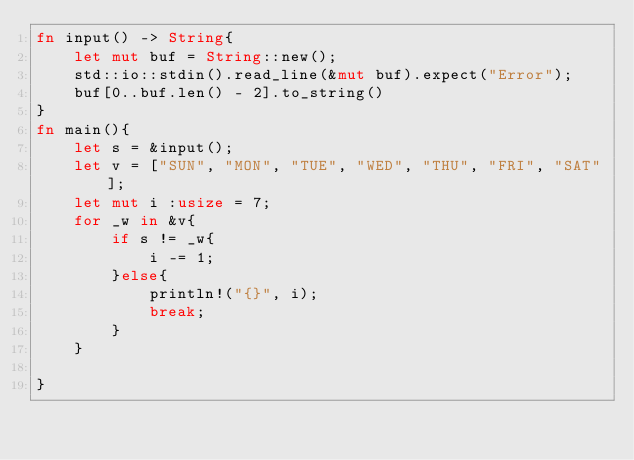<code> <loc_0><loc_0><loc_500><loc_500><_Rust_>fn input() -> String{
    let mut buf = String::new();
    std::io::stdin().read_line(&mut buf).expect("Error");
    buf[0..buf.len() - 2].to_string()
}
fn main(){
    let s = &input();
    let v = ["SUN", "MON", "TUE", "WED", "THU", "FRI", "SAT"];
    let mut i :usize = 7;
    for _w in &v{
        if s != _w{
            i -= 1;
        }else{
            println!("{}", i);
            break;
        }
    }
    
}</code> 